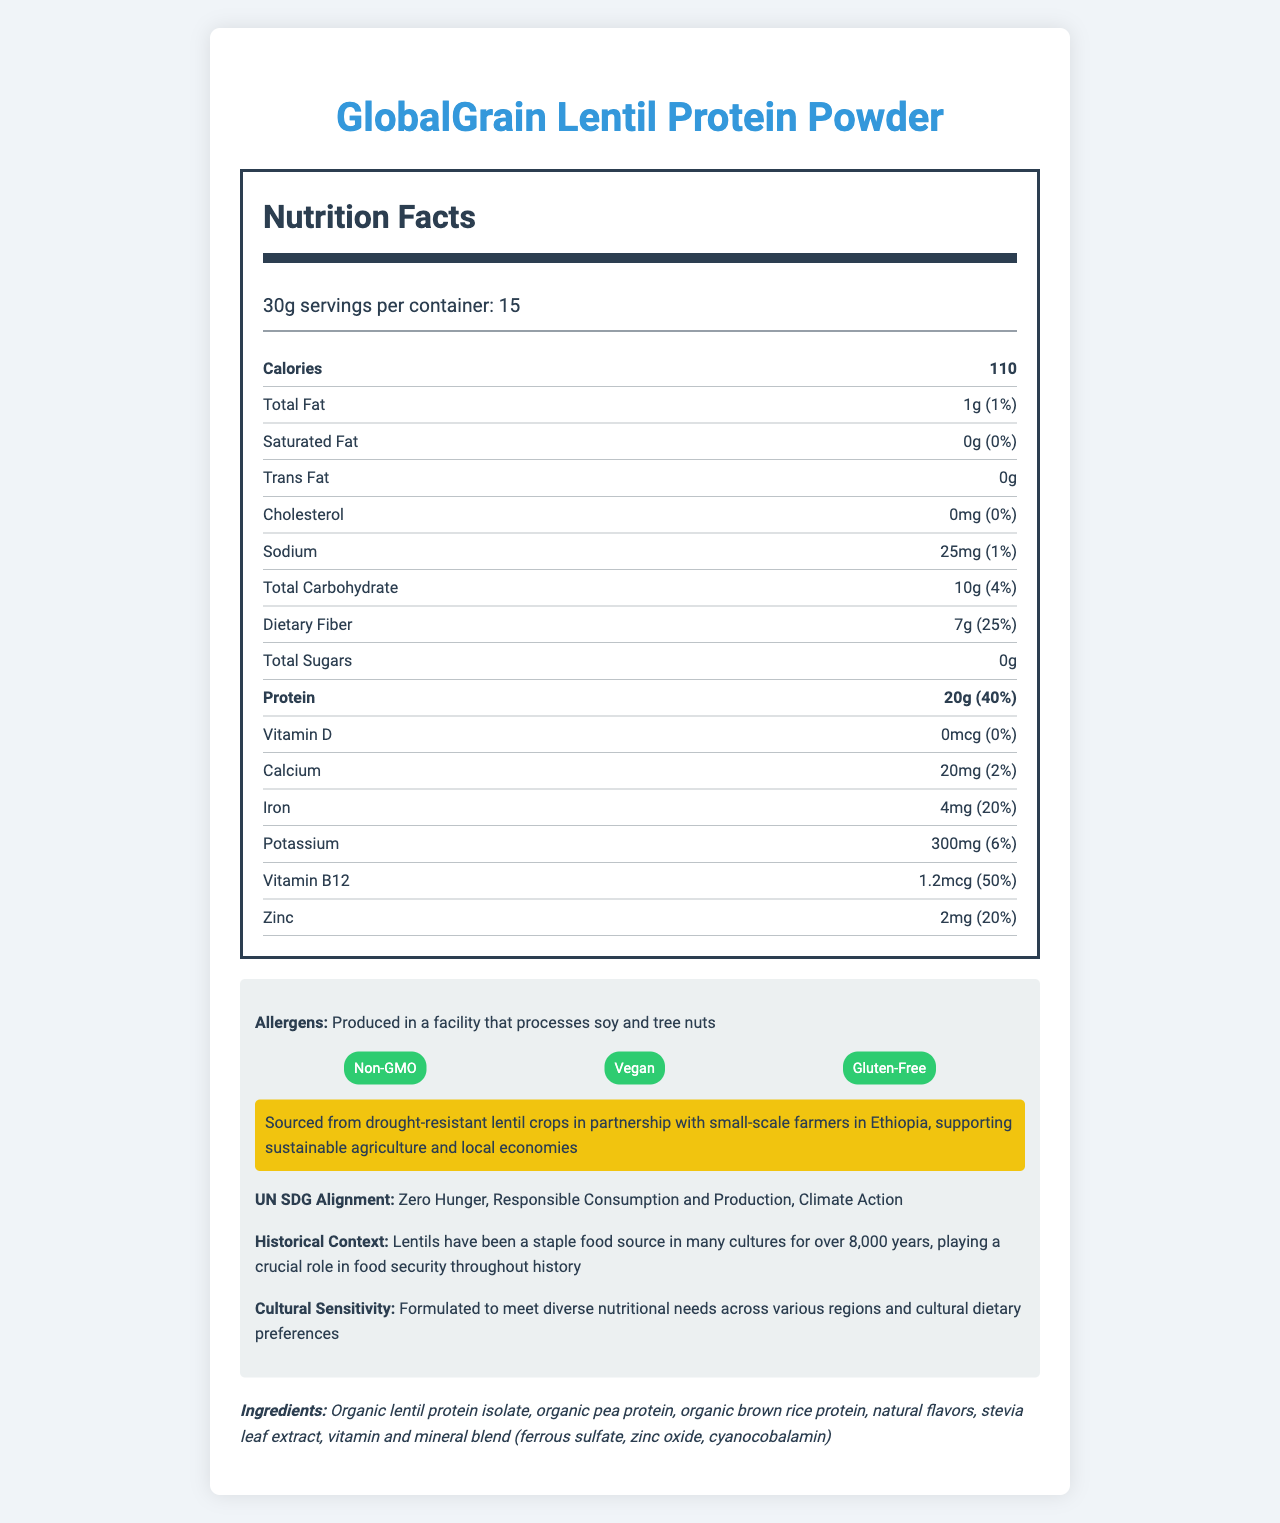what is the serving size? The serving size is listed directly under the product name and serving information.
Answer: 30g how many calories are in one serving? The calories per serving are listed near the top of the nutrition facts section.
Answer: 110 what is the total fat content per serving? Total fat content is shown in the nutrient row with the label "Total Fat."
Answer: 1g what is the daily value percentage of dietary fiber? The daily value percentage for dietary fiber is listed next to its amount.
Answer: 25% how much protein is in a serving? The amount of protein per serving is shown in bold in the nutrition label.
Answer: 20g what percentage of the daily value for calcium does this product provide? A. 1% B. 2% C. 4% D. 6% The daily value percentage for calcium is shown next to its amount in the nutrient row.
Answer: B. 2% which of these certifications does the product have? A. Fair Trade B. Organic C. Gluten-Free D. Kosher The certifications listed under "additional info" include "Non-GMO," "Vegan," and "Gluten-Free."
Answer: C. Gluten-Free is the product suitable for someone with a soy allergy? The product is produced in a facility that processes soy, as indicated in the allergens information.
Answer: No summarize the main idea of this document. The document comprehensively outlines the nutrition, ingredient list, sustainability, and cultural considerations of the GlobalGrain Lentil Protein Powder, highlighting its suitability for international food aid programs and its alignment with sustainable practices and global nutritional needs.
Answer: The document provides detailed nutrition facts and additional information about the "GlobalGrain Lentil Protein Powder," a sustainable and nutritious plant-based protein source suitable for international food aid. It includes serving size, calorie count, nutrient amounts, daily values, allergen information, certifications, sustainability statement, UN SDG alignment, historical context, and cultural sensitivity considerations. what is the historical context provided about lentils? The historical context is detailed in the "additional info" section.
Answer: Lentils have been a staple food source for over 8,000 years and have played a crucial role in food security throughout history. what is the allergen information for this product? The allergen information is listed under "additional info."
Answer: Produced in a facility that processes soy and tree nuts which vitamins and minerals are included in the vitamin and mineral blend? The ingredients list under the nutrition label includes the vitamin and mineral blend.
Answer: Ferrous sulfate, zinc oxide, cyanocobalamin where are the raw materials for this product sourced from? The sustainability statement in the "additional info" section provides this information.
Answer: Sourced from drought-resistant lentil crops in partnership with small-scale farmers in Ethiopia what is the main ingredient of the GlobalGrain Lentil Protein Powder? The ingredients list starts with "Organic lentil protein isolate," indicating it is the main ingredient.
Answer: Organic lentil protein isolate how many servings are there per container? The serving information listed directly under the product name states there are 15 servings per container.
Answer: 15 can we determine the price of the product from this document? The document does not provide any information regarding the price of the product.
Answer: Not enough information 